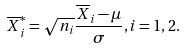<formula> <loc_0><loc_0><loc_500><loc_500>\overline { X } _ { i } ^ { * } = \sqrt { n _ { i } } \frac { \overline { X } _ { i } - \mu } { \sigma } , i = 1 , 2 .</formula> 